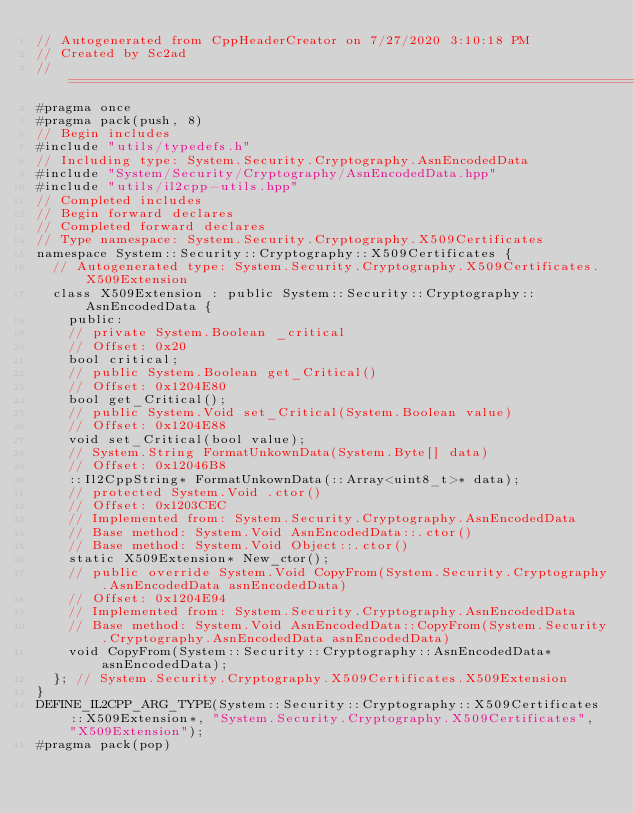Convert code to text. <code><loc_0><loc_0><loc_500><loc_500><_C++_>// Autogenerated from CppHeaderCreator on 7/27/2020 3:10:18 PM
// Created by Sc2ad
// =========================================================================
#pragma once
#pragma pack(push, 8)
// Begin includes
#include "utils/typedefs.h"
// Including type: System.Security.Cryptography.AsnEncodedData
#include "System/Security/Cryptography/AsnEncodedData.hpp"
#include "utils/il2cpp-utils.hpp"
// Completed includes
// Begin forward declares
// Completed forward declares
// Type namespace: System.Security.Cryptography.X509Certificates
namespace System::Security::Cryptography::X509Certificates {
  // Autogenerated type: System.Security.Cryptography.X509Certificates.X509Extension
  class X509Extension : public System::Security::Cryptography::AsnEncodedData {
    public:
    // private System.Boolean _critical
    // Offset: 0x20
    bool critical;
    // public System.Boolean get_Critical()
    // Offset: 0x1204E80
    bool get_Critical();
    // public System.Void set_Critical(System.Boolean value)
    // Offset: 0x1204E88
    void set_Critical(bool value);
    // System.String FormatUnkownData(System.Byte[] data)
    // Offset: 0x12046B8
    ::Il2CppString* FormatUnkownData(::Array<uint8_t>* data);
    // protected System.Void .ctor()
    // Offset: 0x1203CEC
    // Implemented from: System.Security.Cryptography.AsnEncodedData
    // Base method: System.Void AsnEncodedData::.ctor()
    // Base method: System.Void Object::.ctor()
    static X509Extension* New_ctor();
    // public override System.Void CopyFrom(System.Security.Cryptography.AsnEncodedData asnEncodedData)
    // Offset: 0x1204E94
    // Implemented from: System.Security.Cryptography.AsnEncodedData
    // Base method: System.Void AsnEncodedData::CopyFrom(System.Security.Cryptography.AsnEncodedData asnEncodedData)
    void CopyFrom(System::Security::Cryptography::AsnEncodedData* asnEncodedData);
  }; // System.Security.Cryptography.X509Certificates.X509Extension
}
DEFINE_IL2CPP_ARG_TYPE(System::Security::Cryptography::X509Certificates::X509Extension*, "System.Security.Cryptography.X509Certificates", "X509Extension");
#pragma pack(pop)
</code> 